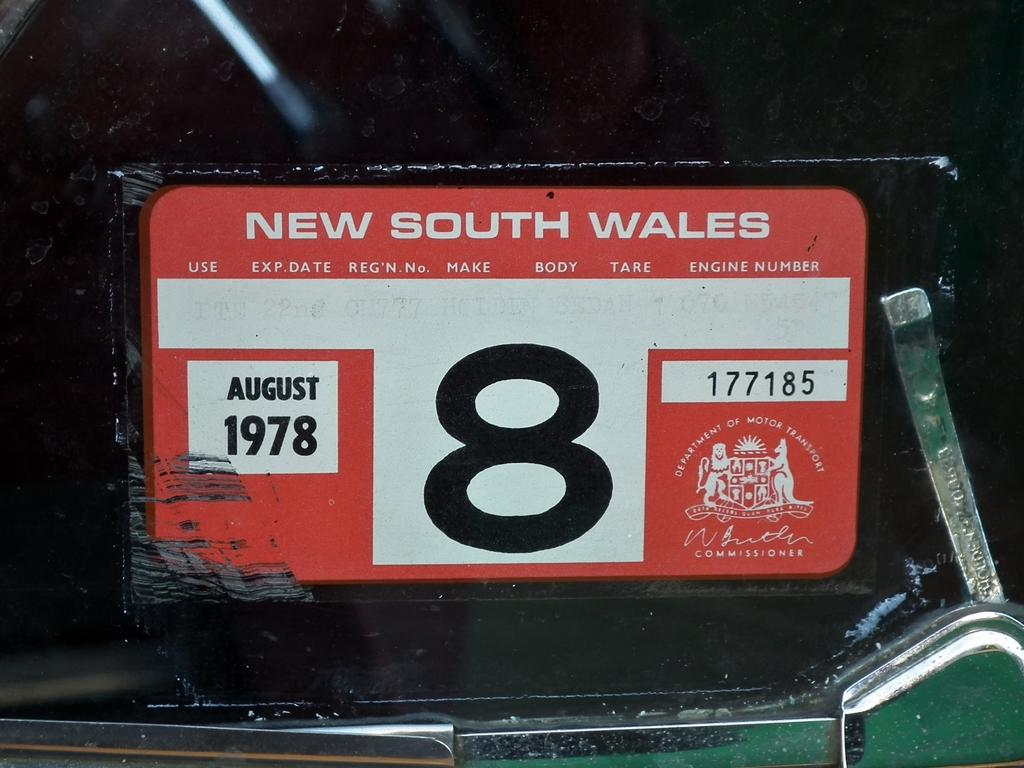<image>
Relay a brief, clear account of the picture shown. A parking permit from 1978 in New South Wales. 